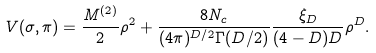<formula> <loc_0><loc_0><loc_500><loc_500>V ( \sigma , \pi ) = \frac { M ^ { ( 2 ) } } { 2 } \rho ^ { 2 } + \frac { 8 N _ { c } } { ( 4 \pi ) ^ { D / 2 } \Gamma ( D / 2 ) } \frac { \xi _ { D } } { ( 4 - D ) D } \rho ^ { D } .</formula> 